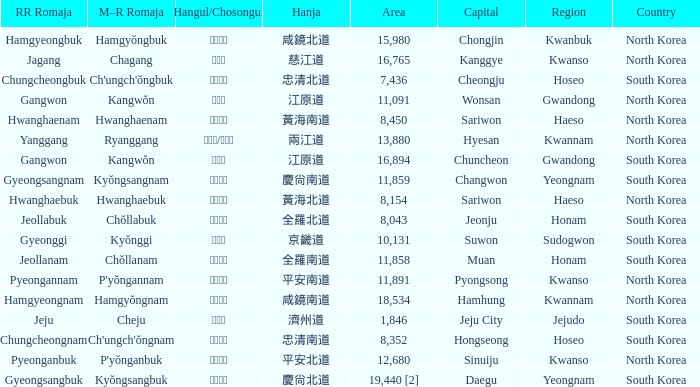What is the RR Romaja for the province that has Hangul of 강원도 and capital of Wonsan? Gangwon. 